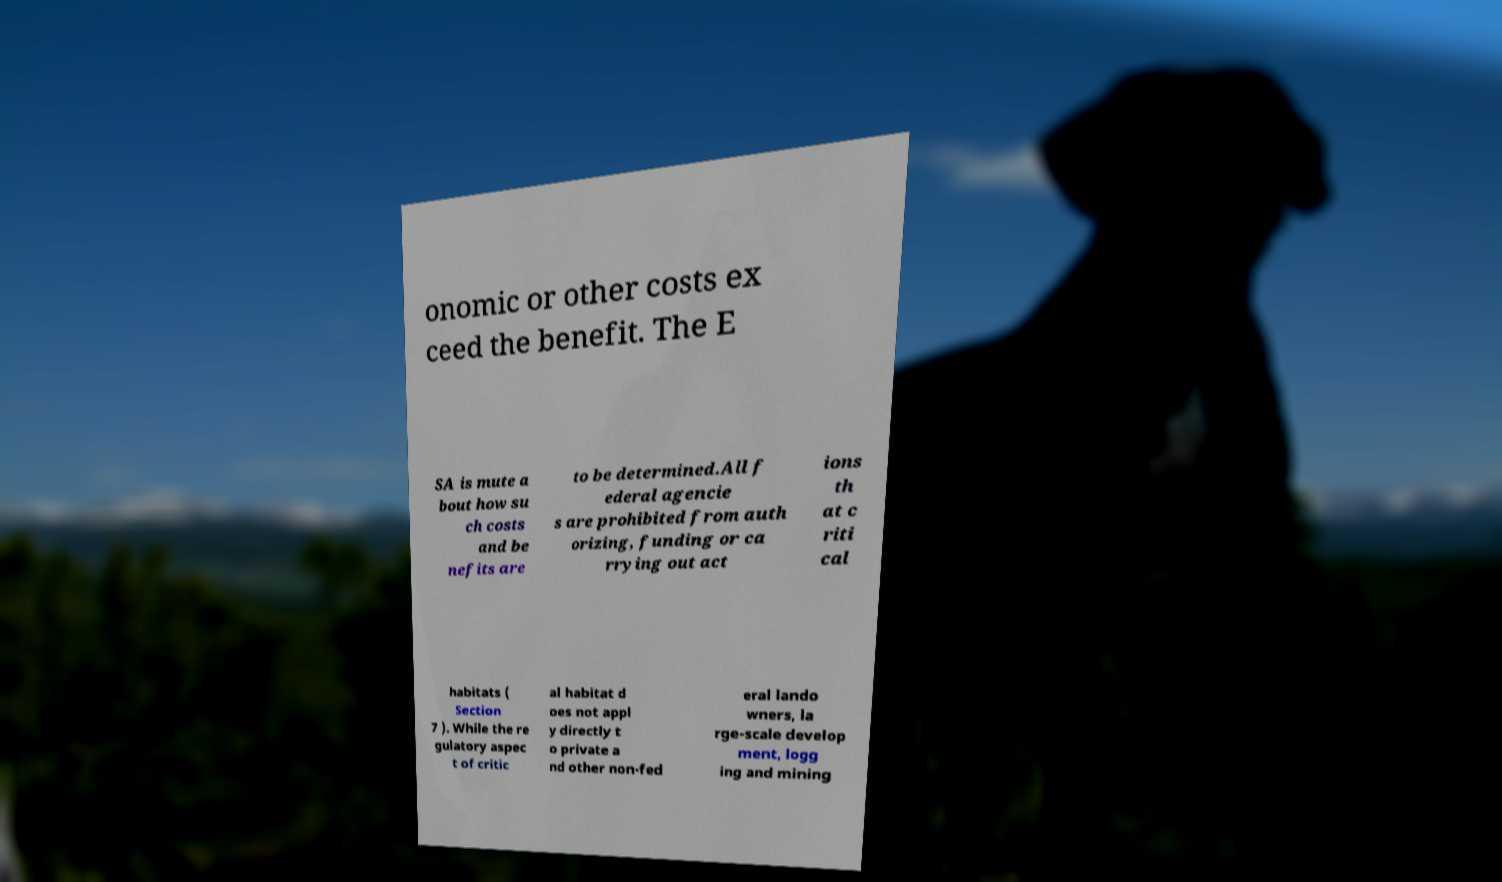Could you extract and type out the text from this image? onomic or other costs ex ceed the benefit. The E SA is mute a bout how su ch costs and be nefits are to be determined.All f ederal agencie s are prohibited from auth orizing, funding or ca rrying out act ions th at c riti cal habitats ( Section 7 ). While the re gulatory aspec t of critic al habitat d oes not appl y directly t o private a nd other non-fed eral lando wners, la rge-scale develop ment, logg ing and mining 